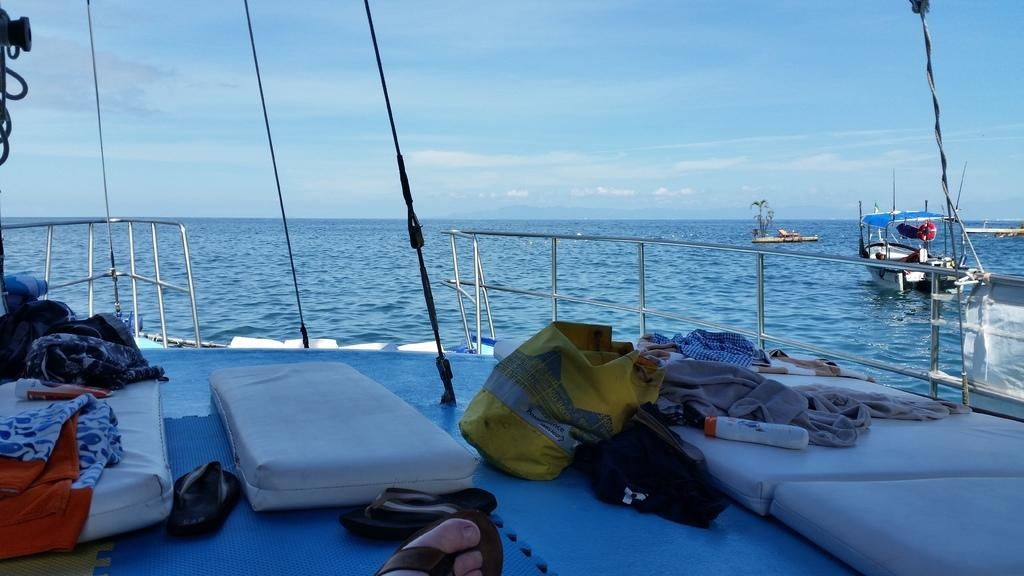What type of items can be seen in the image? There are bags, clothes, mattresses, and foot wears visible in the image. Are there any vehicles in the image? Yes, there are ships visible on the water surface. What is the color of the sky in the image? The sky is blue and white in color. What objects can be found inside the ship? There are objects in the ship visible in the image. Where is the nest located in the image? There is no nest present in the image. What type of cloth is used to make the bags in the image? The provided facts do not specify the type of cloth used to make the bags in the image. 